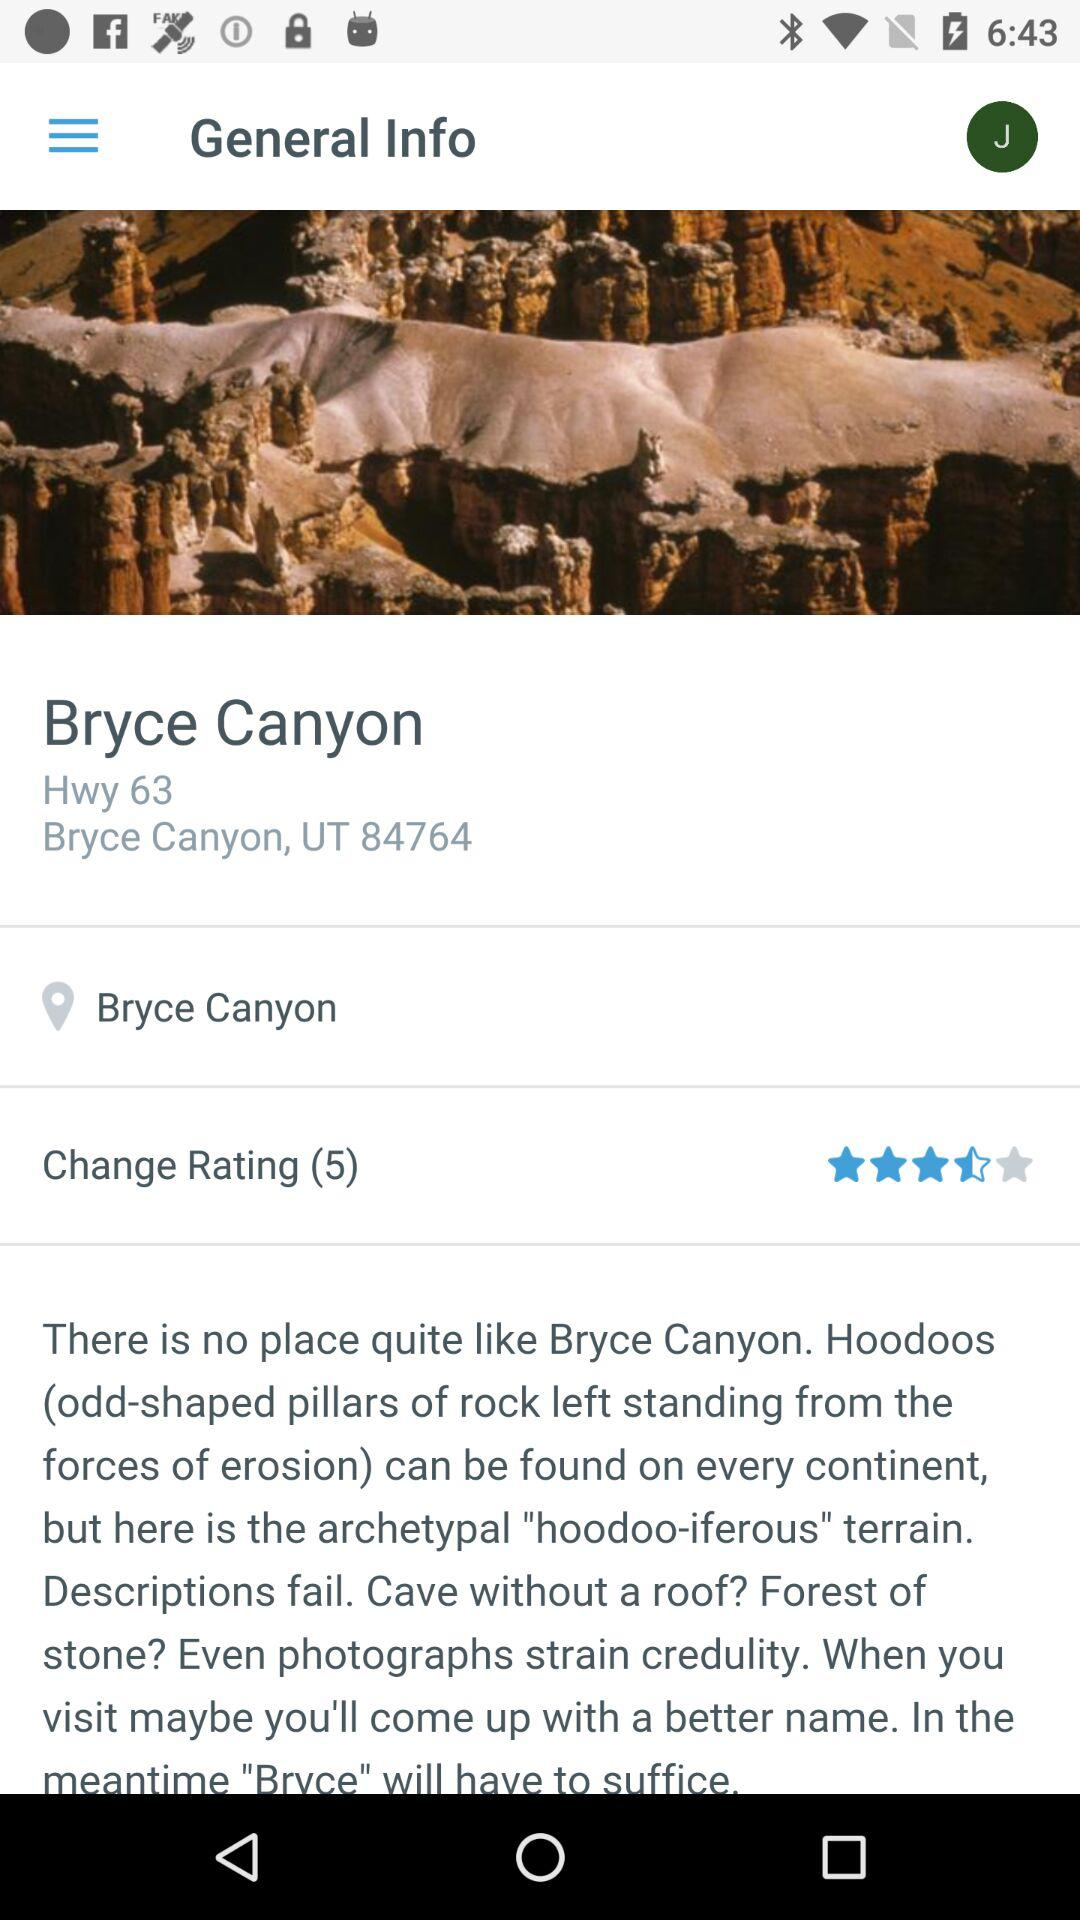What is the location? The location is Highway 63, Bryce Canyon, UT 84764. 